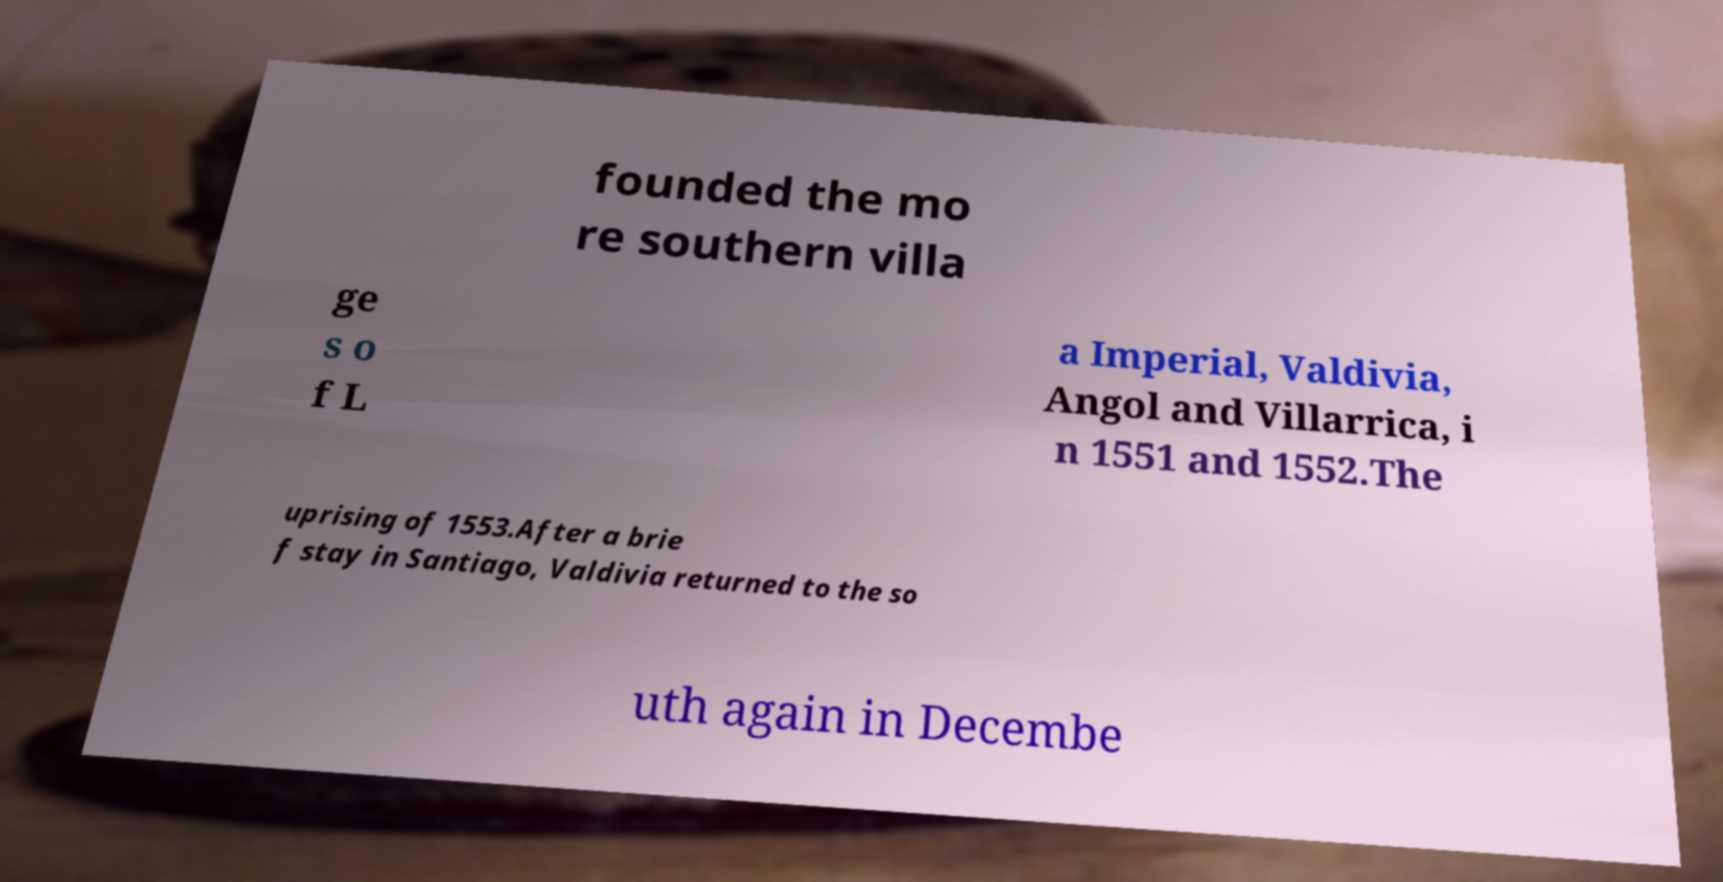There's text embedded in this image that I need extracted. Can you transcribe it verbatim? founded the mo re southern villa ge s o f L a Imperial, Valdivia, Angol and Villarrica, i n 1551 and 1552.The uprising of 1553.After a brie f stay in Santiago, Valdivia returned to the so uth again in Decembe 